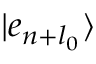<formula> <loc_0><loc_0><loc_500><loc_500>| e _ { n + l _ { 0 } } \rangle</formula> 